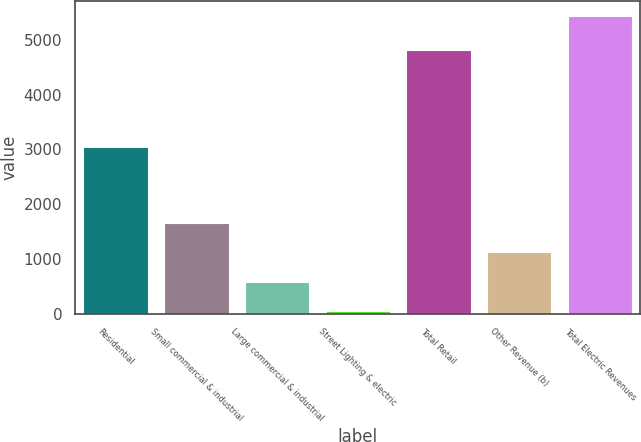<chart> <loc_0><loc_0><loc_500><loc_500><bar_chart><fcel>Residential<fcel>Small commercial & industrial<fcel>Large commercial & industrial<fcel>Street Lighting & electric<fcel>Total Retail<fcel>Other Revenue (b)<fcel>Total Electric Revenues<nl><fcel>3037<fcel>1663.7<fcel>583.9<fcel>44<fcel>4815<fcel>1123.8<fcel>5443<nl></chart> 